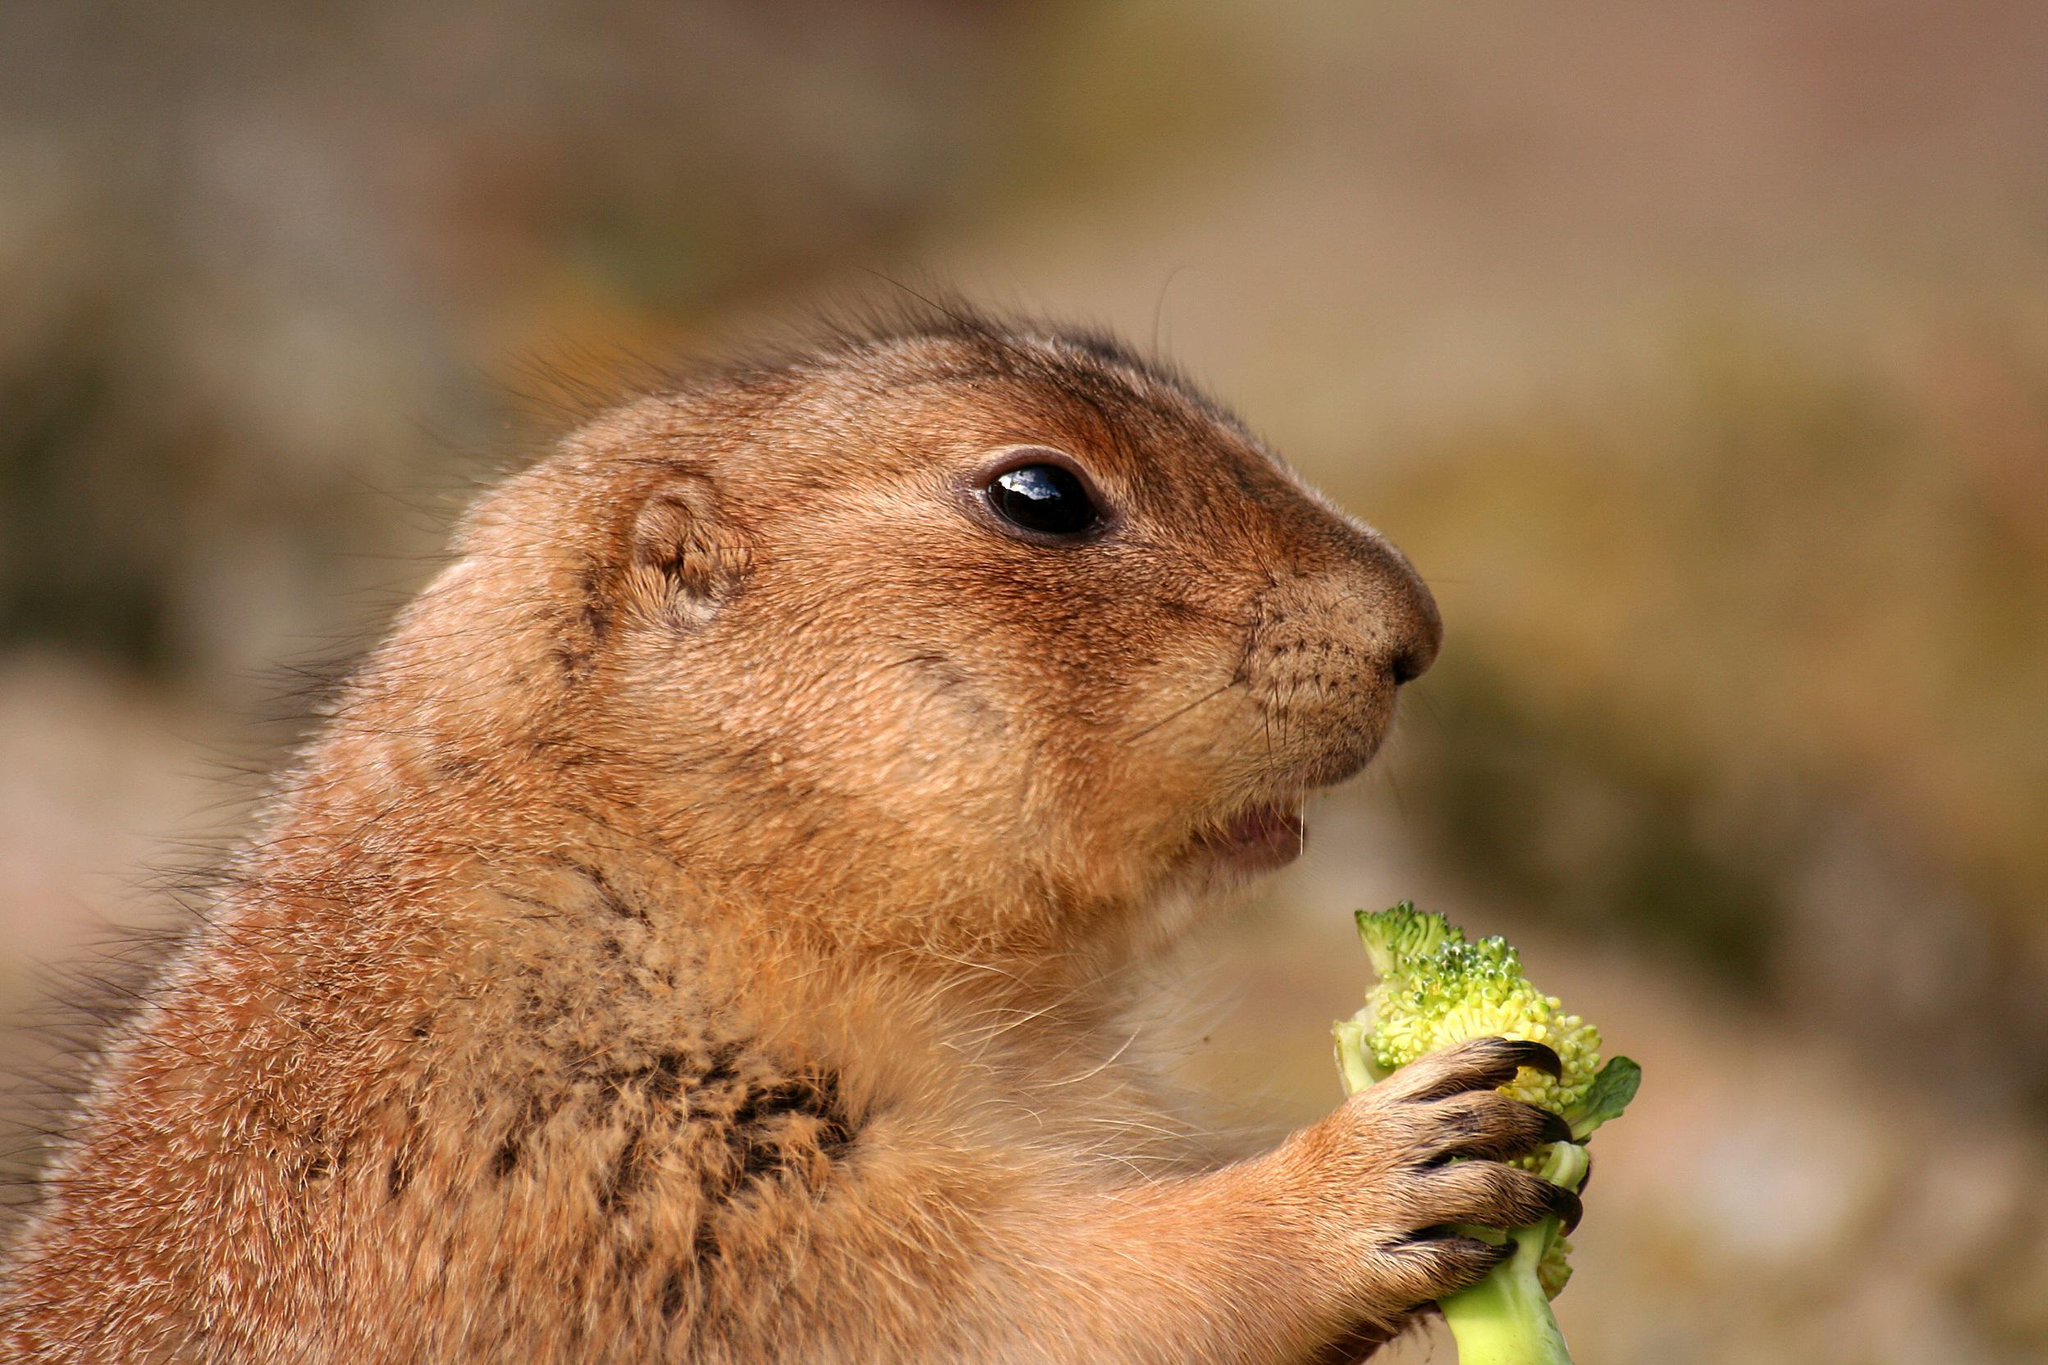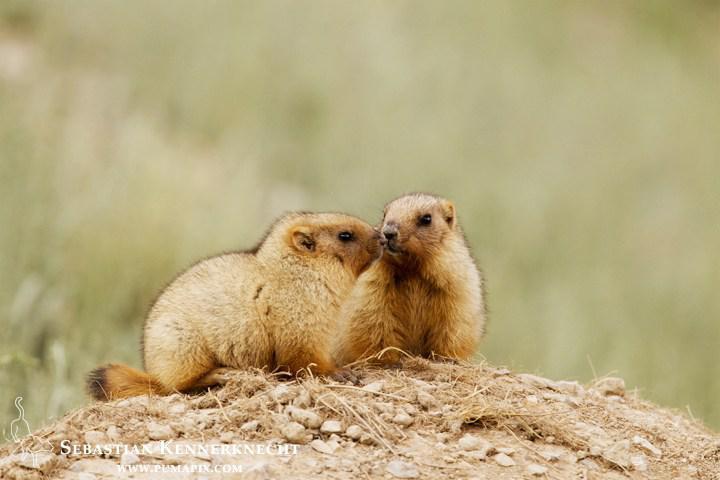The first image is the image on the left, the second image is the image on the right. Considering the images on both sides, is "There are our groundhogs." valid? Answer yes or no. No. 